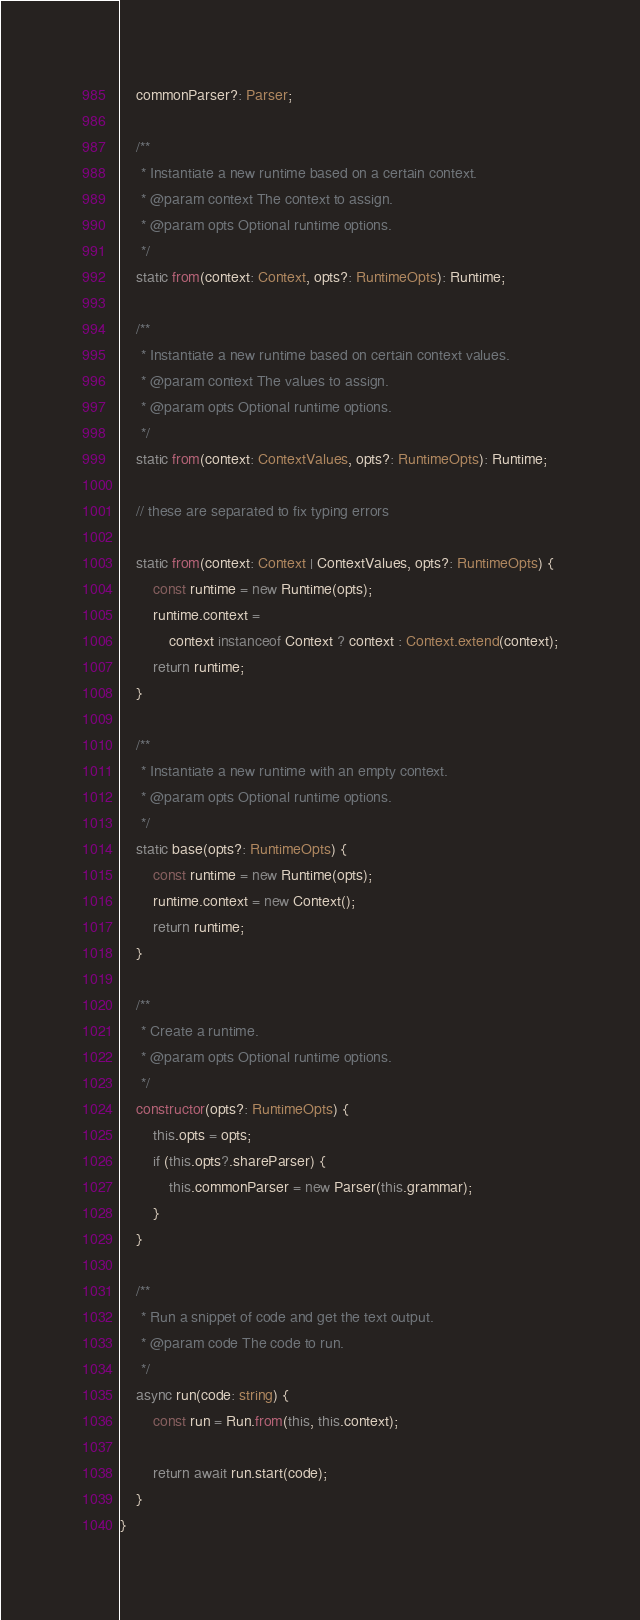Convert code to text. <code><loc_0><loc_0><loc_500><loc_500><_TypeScript_>    commonParser?: Parser;

    /**
     * Instantiate a new runtime based on a certain context.
     * @param context The context to assign.
     * @param opts Optional runtime options.
     */
    static from(context: Context, opts?: RuntimeOpts): Runtime;

    /**
     * Instantiate a new runtime based on certain context values.
     * @param context The values to assign.
     * @param opts Optional runtime options.
     */
    static from(context: ContextValues, opts?: RuntimeOpts): Runtime;

    // these are separated to fix typing errors

    static from(context: Context | ContextValues, opts?: RuntimeOpts) {
        const runtime = new Runtime(opts);
        runtime.context =
            context instanceof Context ? context : Context.extend(context);
        return runtime;
    }

    /**
     * Instantiate a new runtime with an empty context.
     * @param opts Optional runtime options.
     */
    static base(opts?: RuntimeOpts) {
        const runtime = new Runtime(opts);
        runtime.context = new Context();
        return runtime;
    }

    /**
     * Create a runtime.
     * @param opts Optional runtime options.
     */
    constructor(opts?: RuntimeOpts) {
        this.opts = opts;
        if (this.opts?.shareParser) {
            this.commonParser = new Parser(this.grammar);
        }
    }

    /**
     * Run a snippet of code and get the text output.
     * @param code The code to run.
     */
    async run(code: string) {
        const run = Run.from(this, this.context);

        return await run.start(code);
    }
}
</code> 